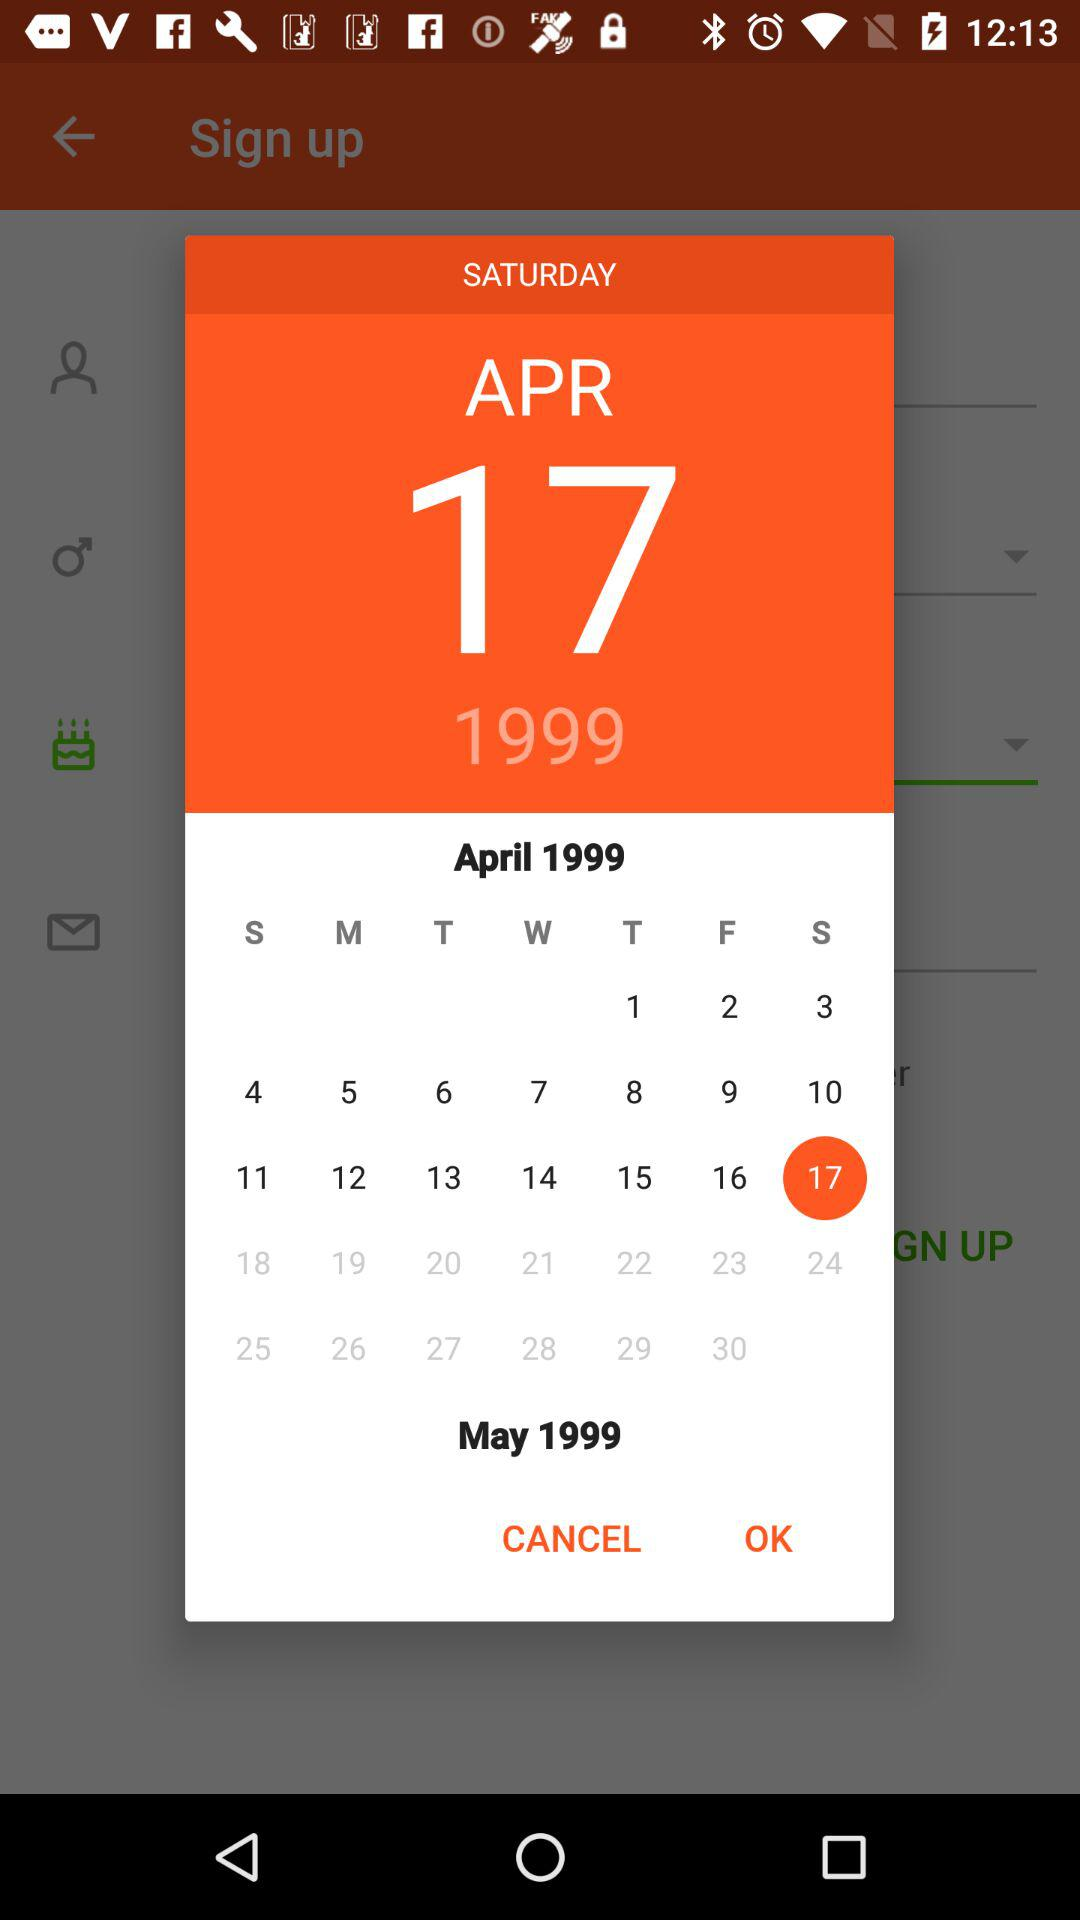Which month has been chosen? The month chosen is April. 